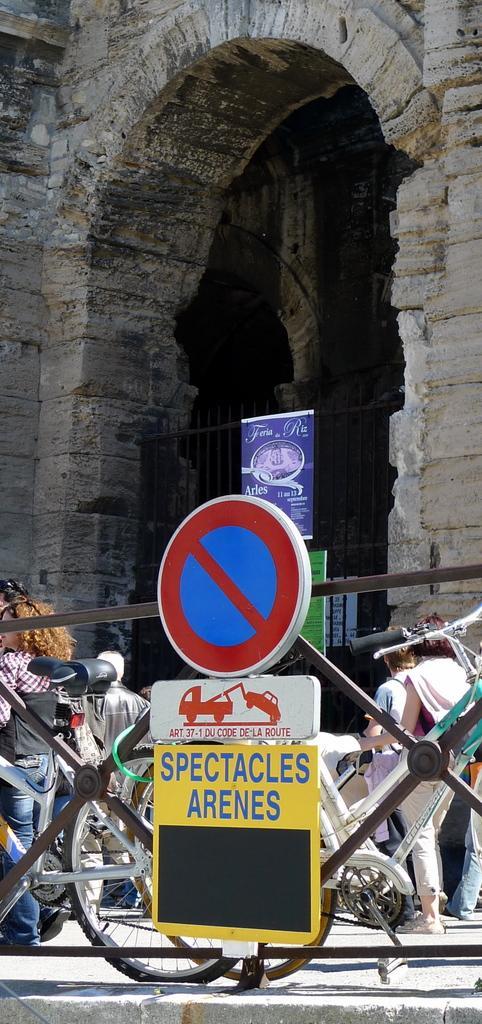How would you summarize this image in a sentence or two? In this image I can see the boards to the railing. To the side of the railing I can see the group of people and the bicycles. In the background I can see the building and few more boards attached to the railing. 